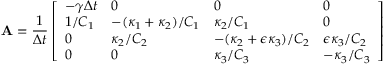<formula> <loc_0><loc_0><loc_500><loc_500>A = \frac { 1 } { \Delta t } \left [ \begin{array} { l l l l } { - \gamma \Delta t } & { 0 } & { 0 } & { 0 } \\ { 1 / C _ { 1 } } & { - ( \kappa _ { 1 } + \kappa _ { 2 } ) / C _ { 1 } } & { \kappa _ { 2 } / C _ { 1 } } & { 0 } \\ { 0 } & { \kappa _ { 2 } / C _ { 2 } } & { - ( \kappa _ { 2 } + \epsilon \kappa _ { 3 } ) / C _ { 2 } } & { \epsilon \kappa _ { 3 } / C _ { 2 } } \\ { 0 } & { 0 } & { \kappa _ { 3 } / C _ { 3 } } & { - \kappa _ { 3 } / C _ { 3 } } \end{array} \right ]</formula> 